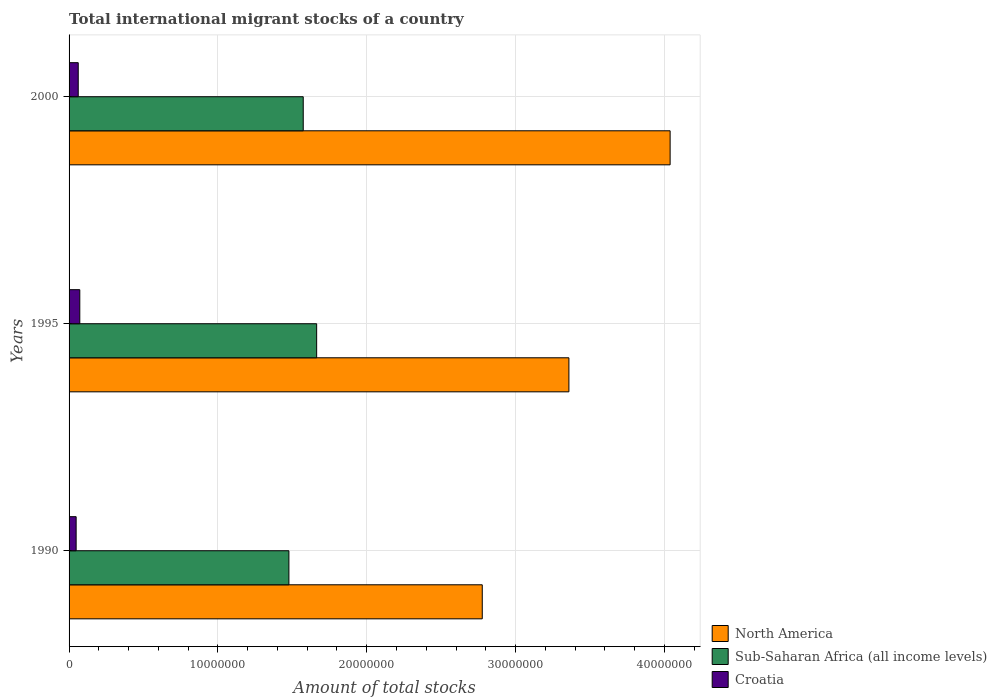How many different coloured bars are there?
Your answer should be compact. 3. Are the number of bars per tick equal to the number of legend labels?
Offer a terse response. Yes. Are the number of bars on each tick of the Y-axis equal?
Your response must be concise. Yes. How many bars are there on the 3rd tick from the bottom?
Keep it short and to the point. 3. What is the label of the 3rd group of bars from the top?
Give a very brief answer. 1990. In how many cases, is the number of bars for a given year not equal to the number of legend labels?
Offer a terse response. 0. What is the amount of total stocks in in North America in 1990?
Your answer should be very brief. 2.78e+07. Across all years, what is the maximum amount of total stocks in in Sub-Saharan Africa (all income levels)?
Make the answer very short. 1.66e+07. Across all years, what is the minimum amount of total stocks in in Croatia?
Keep it short and to the point. 4.75e+05. In which year was the amount of total stocks in in North America minimum?
Make the answer very short. 1990. What is the total amount of total stocks in in North America in the graph?
Your answer should be very brief. 1.02e+08. What is the difference between the amount of total stocks in in Sub-Saharan Africa (all income levels) in 1995 and that in 2000?
Your answer should be compact. 9.01e+05. What is the difference between the amount of total stocks in in Croatia in 1990 and the amount of total stocks in in North America in 1995?
Your response must be concise. -3.31e+07. What is the average amount of total stocks in in Croatia per year?
Ensure brevity in your answer.  6.04e+05. In the year 1990, what is the difference between the amount of total stocks in in North America and amount of total stocks in in Croatia?
Ensure brevity in your answer.  2.73e+07. What is the ratio of the amount of total stocks in in North America in 1990 to that in 2000?
Ensure brevity in your answer.  0.69. Is the difference between the amount of total stocks in in North America in 1990 and 2000 greater than the difference between the amount of total stocks in in Croatia in 1990 and 2000?
Your answer should be very brief. No. What is the difference between the highest and the second highest amount of total stocks in in Sub-Saharan Africa (all income levels)?
Offer a very short reply. 9.01e+05. What is the difference between the highest and the lowest amount of total stocks in in Sub-Saharan Africa (all income levels)?
Offer a very short reply. 1.86e+06. Is the sum of the amount of total stocks in in North America in 1990 and 1995 greater than the maximum amount of total stocks in in Sub-Saharan Africa (all income levels) across all years?
Provide a succinct answer. Yes. What does the 1st bar from the top in 1990 represents?
Keep it short and to the point. Croatia. What does the 3rd bar from the bottom in 1995 represents?
Give a very brief answer. Croatia. How many bars are there?
Ensure brevity in your answer.  9. Are all the bars in the graph horizontal?
Give a very brief answer. Yes. How many years are there in the graph?
Make the answer very short. 3. What is the difference between two consecutive major ticks on the X-axis?
Keep it short and to the point. 1.00e+07. Does the graph contain any zero values?
Offer a very short reply. No. Where does the legend appear in the graph?
Keep it short and to the point. Bottom right. What is the title of the graph?
Provide a succinct answer. Total international migrant stocks of a country. What is the label or title of the X-axis?
Offer a very short reply. Amount of total stocks. What is the Amount of total stocks of North America in 1990?
Your answer should be compact. 2.78e+07. What is the Amount of total stocks of Sub-Saharan Africa (all income levels) in 1990?
Give a very brief answer. 1.48e+07. What is the Amount of total stocks in Croatia in 1990?
Offer a very short reply. 4.75e+05. What is the Amount of total stocks of North America in 1995?
Offer a very short reply. 3.36e+07. What is the Amount of total stocks of Sub-Saharan Africa (all income levels) in 1995?
Make the answer very short. 1.66e+07. What is the Amount of total stocks in Croatia in 1995?
Your answer should be compact. 7.21e+05. What is the Amount of total stocks of North America in 2000?
Make the answer very short. 4.04e+07. What is the Amount of total stocks of Sub-Saharan Africa (all income levels) in 2000?
Provide a short and direct response. 1.57e+07. What is the Amount of total stocks of Croatia in 2000?
Provide a short and direct response. 6.16e+05. Across all years, what is the maximum Amount of total stocks in North America?
Offer a terse response. 4.04e+07. Across all years, what is the maximum Amount of total stocks in Sub-Saharan Africa (all income levels)?
Keep it short and to the point. 1.66e+07. Across all years, what is the maximum Amount of total stocks of Croatia?
Keep it short and to the point. 7.21e+05. Across all years, what is the minimum Amount of total stocks in North America?
Give a very brief answer. 2.78e+07. Across all years, what is the minimum Amount of total stocks in Sub-Saharan Africa (all income levels)?
Keep it short and to the point. 1.48e+07. Across all years, what is the minimum Amount of total stocks in Croatia?
Give a very brief answer. 4.75e+05. What is the total Amount of total stocks of North America in the graph?
Offer a terse response. 1.02e+08. What is the total Amount of total stocks of Sub-Saharan Africa (all income levels) in the graph?
Give a very brief answer. 4.71e+07. What is the total Amount of total stocks of Croatia in the graph?
Provide a succinct answer. 1.81e+06. What is the difference between the Amount of total stocks in North America in 1990 and that in 1995?
Your response must be concise. -5.82e+06. What is the difference between the Amount of total stocks of Sub-Saharan Africa (all income levels) in 1990 and that in 1995?
Provide a short and direct response. -1.86e+06. What is the difference between the Amount of total stocks of Croatia in 1990 and that in 1995?
Your answer should be compact. -2.46e+05. What is the difference between the Amount of total stocks of North America in 1990 and that in 2000?
Ensure brevity in your answer.  -1.26e+07. What is the difference between the Amount of total stocks of Sub-Saharan Africa (all income levels) in 1990 and that in 2000?
Make the answer very short. -9.63e+05. What is the difference between the Amount of total stocks in Croatia in 1990 and that in 2000?
Your answer should be compact. -1.40e+05. What is the difference between the Amount of total stocks in North America in 1995 and that in 2000?
Offer a terse response. -6.80e+06. What is the difference between the Amount of total stocks in Sub-Saharan Africa (all income levels) in 1995 and that in 2000?
Give a very brief answer. 9.01e+05. What is the difference between the Amount of total stocks of Croatia in 1995 and that in 2000?
Provide a succinct answer. 1.05e+05. What is the difference between the Amount of total stocks in North America in 1990 and the Amount of total stocks in Sub-Saharan Africa (all income levels) in 1995?
Make the answer very short. 1.11e+07. What is the difference between the Amount of total stocks of North America in 1990 and the Amount of total stocks of Croatia in 1995?
Ensure brevity in your answer.  2.70e+07. What is the difference between the Amount of total stocks in Sub-Saharan Africa (all income levels) in 1990 and the Amount of total stocks in Croatia in 1995?
Offer a very short reply. 1.41e+07. What is the difference between the Amount of total stocks of North America in 1990 and the Amount of total stocks of Sub-Saharan Africa (all income levels) in 2000?
Offer a terse response. 1.20e+07. What is the difference between the Amount of total stocks in North America in 1990 and the Amount of total stocks in Croatia in 2000?
Offer a very short reply. 2.71e+07. What is the difference between the Amount of total stocks of Sub-Saharan Africa (all income levels) in 1990 and the Amount of total stocks of Croatia in 2000?
Your answer should be compact. 1.42e+07. What is the difference between the Amount of total stocks in North America in 1995 and the Amount of total stocks in Sub-Saharan Africa (all income levels) in 2000?
Offer a terse response. 1.79e+07. What is the difference between the Amount of total stocks of North America in 1995 and the Amount of total stocks of Croatia in 2000?
Your response must be concise. 3.30e+07. What is the difference between the Amount of total stocks of Sub-Saharan Africa (all income levels) in 1995 and the Amount of total stocks of Croatia in 2000?
Provide a short and direct response. 1.60e+07. What is the average Amount of total stocks in North America per year?
Give a very brief answer. 3.39e+07. What is the average Amount of total stocks of Sub-Saharan Africa (all income levels) per year?
Offer a terse response. 1.57e+07. What is the average Amount of total stocks of Croatia per year?
Offer a terse response. 6.04e+05. In the year 1990, what is the difference between the Amount of total stocks in North America and Amount of total stocks in Sub-Saharan Africa (all income levels)?
Make the answer very short. 1.30e+07. In the year 1990, what is the difference between the Amount of total stocks of North America and Amount of total stocks of Croatia?
Make the answer very short. 2.73e+07. In the year 1990, what is the difference between the Amount of total stocks of Sub-Saharan Africa (all income levels) and Amount of total stocks of Croatia?
Give a very brief answer. 1.43e+07. In the year 1995, what is the difference between the Amount of total stocks of North America and Amount of total stocks of Sub-Saharan Africa (all income levels)?
Your response must be concise. 1.70e+07. In the year 1995, what is the difference between the Amount of total stocks in North America and Amount of total stocks in Croatia?
Your answer should be compact. 3.29e+07. In the year 1995, what is the difference between the Amount of total stocks in Sub-Saharan Africa (all income levels) and Amount of total stocks in Croatia?
Provide a short and direct response. 1.59e+07. In the year 2000, what is the difference between the Amount of total stocks in North America and Amount of total stocks in Sub-Saharan Africa (all income levels)?
Provide a succinct answer. 2.47e+07. In the year 2000, what is the difference between the Amount of total stocks of North America and Amount of total stocks of Croatia?
Ensure brevity in your answer.  3.98e+07. In the year 2000, what is the difference between the Amount of total stocks of Sub-Saharan Africa (all income levels) and Amount of total stocks of Croatia?
Make the answer very short. 1.51e+07. What is the ratio of the Amount of total stocks of North America in 1990 to that in 1995?
Offer a terse response. 0.83. What is the ratio of the Amount of total stocks of Sub-Saharan Africa (all income levels) in 1990 to that in 1995?
Make the answer very short. 0.89. What is the ratio of the Amount of total stocks in Croatia in 1990 to that in 1995?
Your answer should be compact. 0.66. What is the ratio of the Amount of total stocks of North America in 1990 to that in 2000?
Make the answer very short. 0.69. What is the ratio of the Amount of total stocks of Sub-Saharan Africa (all income levels) in 1990 to that in 2000?
Your response must be concise. 0.94. What is the ratio of the Amount of total stocks in Croatia in 1990 to that in 2000?
Your answer should be very brief. 0.77. What is the ratio of the Amount of total stocks of North America in 1995 to that in 2000?
Keep it short and to the point. 0.83. What is the ratio of the Amount of total stocks in Sub-Saharan Africa (all income levels) in 1995 to that in 2000?
Give a very brief answer. 1.06. What is the ratio of the Amount of total stocks in Croatia in 1995 to that in 2000?
Offer a very short reply. 1.17. What is the difference between the highest and the second highest Amount of total stocks of North America?
Ensure brevity in your answer.  6.80e+06. What is the difference between the highest and the second highest Amount of total stocks in Sub-Saharan Africa (all income levels)?
Offer a terse response. 9.01e+05. What is the difference between the highest and the second highest Amount of total stocks in Croatia?
Keep it short and to the point. 1.05e+05. What is the difference between the highest and the lowest Amount of total stocks in North America?
Your answer should be very brief. 1.26e+07. What is the difference between the highest and the lowest Amount of total stocks of Sub-Saharan Africa (all income levels)?
Your response must be concise. 1.86e+06. What is the difference between the highest and the lowest Amount of total stocks of Croatia?
Your answer should be compact. 2.46e+05. 